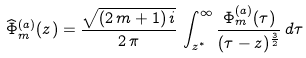<formula> <loc_0><loc_0><loc_500><loc_500>\widehat { \Phi } _ { m } ^ { ( a ) } ( z ) = \frac { \sqrt { ( 2 \, m + 1 ) \, i } } { 2 \, \pi } \, \int _ { z ^ { * } } ^ { \infty } \frac { \Phi _ { m } ^ { ( a ) } ( \tau ) } { ( \tau - z ) ^ { \frac { 3 } { 2 } } } \, d \tau</formula> 